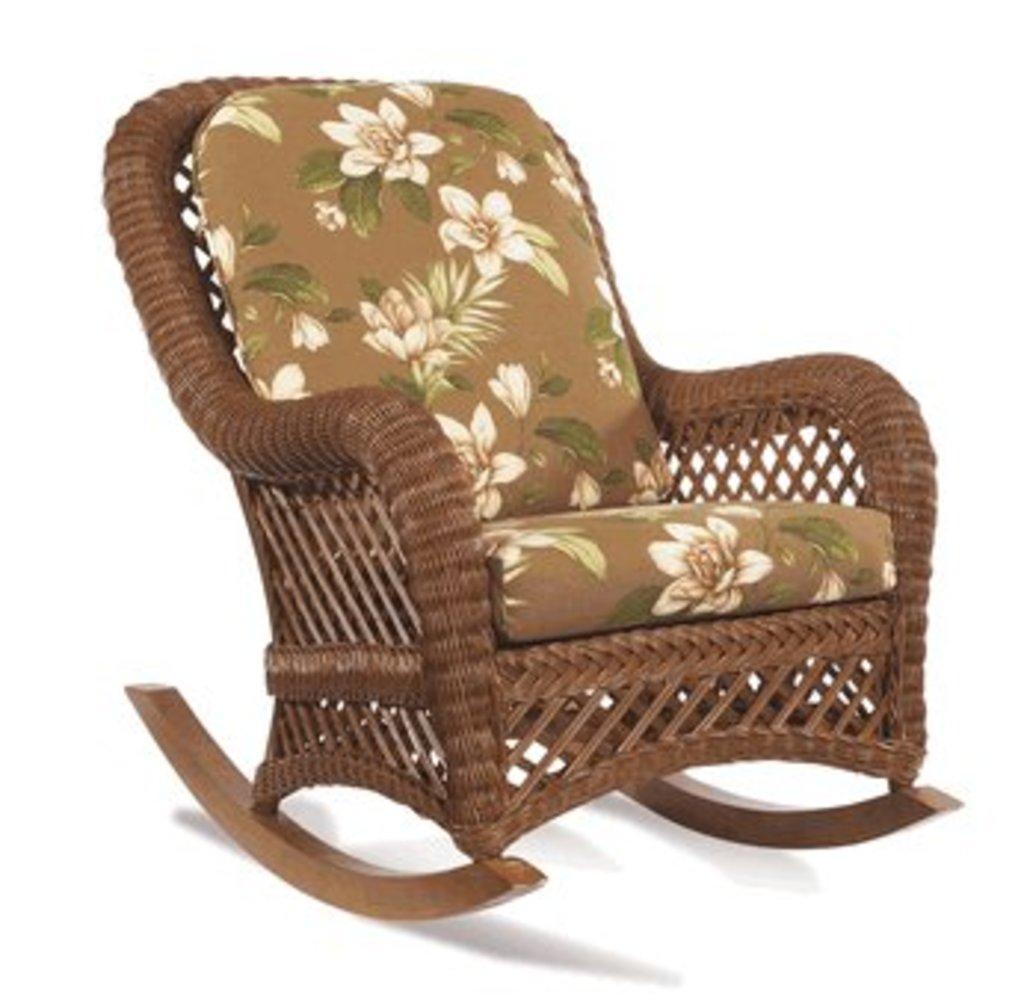Please provide a concise description of this image. In this image, I can see a chair and a white color background. 